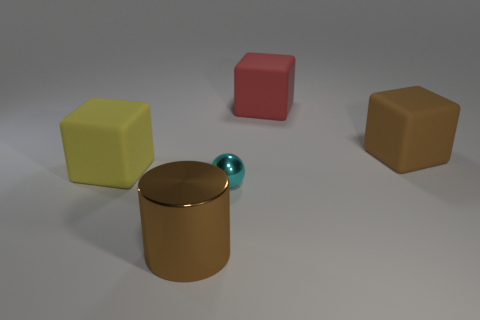What number of cylinders are brown metal things or tiny cyan rubber things?
Offer a terse response. 1. There is a small object that is the same material as the cylinder; what is its color?
Ensure brevity in your answer.  Cyan. There is a brown object that is behind the yellow rubber block; does it have the same size as the cyan metal object?
Ensure brevity in your answer.  No. Are the tiny cyan thing and the large block to the left of the ball made of the same material?
Offer a very short reply. No. What is the color of the object that is left of the large brown metal object?
Your answer should be compact. Yellow. There is a large brown thing in front of the sphere; are there any large metal objects to the left of it?
Keep it short and to the point. No. Does the big thing that is in front of the big yellow block have the same color as the big matte object right of the big red cube?
Give a very brief answer. Yes. There is a big brown matte thing; how many large rubber objects are in front of it?
Make the answer very short. 1. How many big cubes have the same color as the tiny sphere?
Provide a short and direct response. 0. Do the cube that is left of the metal ball and the large brown cube have the same material?
Your response must be concise. Yes. 